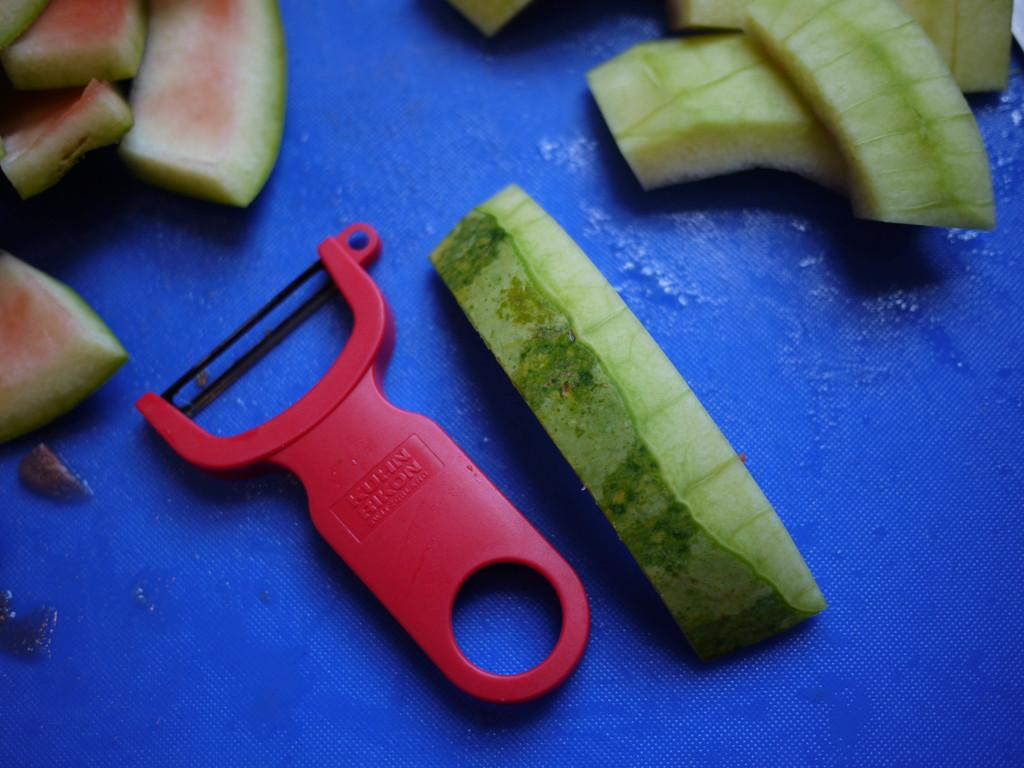What kitchen tool is visible in the image? There is a peeler in the image. What is the result of using the peeler in the image? There are peels of watermelon in the image. Where are the peeler and watermelon peels located? The peeler and watermelon peels are on a platform. What type of representative is present in the image? There is no representative present in the image; it features a peeler and watermelon peels on a platform. Is there a railway visible in the image? There is no railway present in the image. What type of clothing accessory is visible in the image? There is no scarf or any clothing accessory present in the image. 